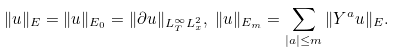Convert formula to latex. <formula><loc_0><loc_0><loc_500><loc_500>& \| u \| _ { E } = \| u \| _ { E _ { 0 } } = \| \partial u \| _ { L _ { T } ^ { \infty } L _ { x } ^ { 2 } } , \ \| u \| _ { E _ { m } } = \sum _ { | a | \leq m } \| Y ^ { a } u \| _ { E } .</formula> 